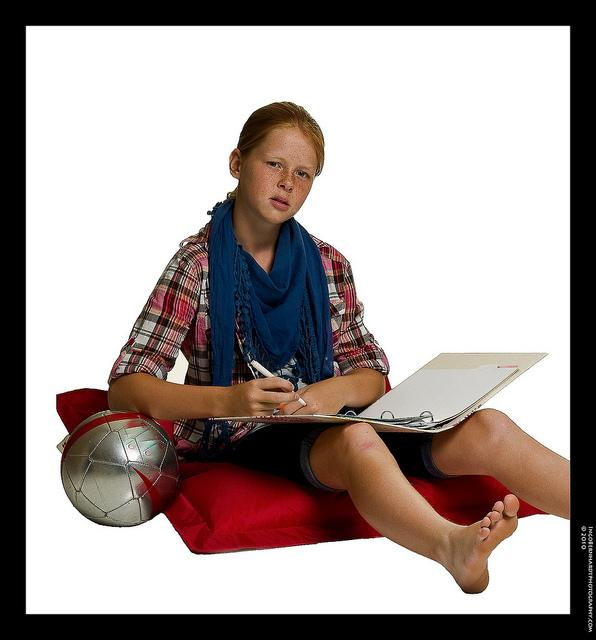What happened to the background? Please explain your reasoning. edited out. The background is completely white. 